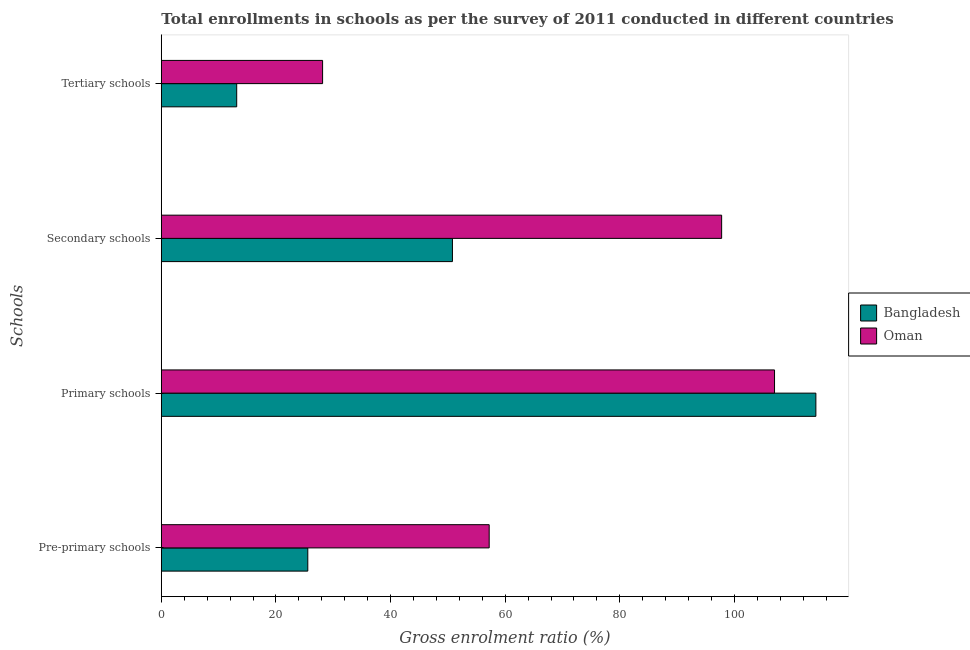How many different coloured bars are there?
Your answer should be very brief. 2. How many groups of bars are there?
Provide a short and direct response. 4. Are the number of bars per tick equal to the number of legend labels?
Provide a succinct answer. Yes. How many bars are there on the 1st tick from the top?
Offer a very short reply. 2. What is the label of the 1st group of bars from the top?
Your response must be concise. Tertiary schools. What is the gross enrolment ratio in tertiary schools in Oman?
Offer a terse response. 28.14. Across all countries, what is the maximum gross enrolment ratio in tertiary schools?
Offer a very short reply. 28.14. Across all countries, what is the minimum gross enrolment ratio in tertiary schools?
Ensure brevity in your answer.  13.15. In which country was the gross enrolment ratio in primary schools maximum?
Give a very brief answer. Bangladesh. In which country was the gross enrolment ratio in primary schools minimum?
Your answer should be compact. Oman. What is the total gross enrolment ratio in primary schools in the graph?
Your answer should be very brief. 221.19. What is the difference between the gross enrolment ratio in pre-primary schools in Bangladesh and that in Oman?
Offer a terse response. -31.65. What is the difference between the gross enrolment ratio in secondary schools in Oman and the gross enrolment ratio in tertiary schools in Bangladesh?
Make the answer very short. 84.61. What is the average gross enrolment ratio in pre-primary schools per country?
Give a very brief answer. 41.38. What is the difference between the gross enrolment ratio in primary schools and gross enrolment ratio in secondary schools in Bangladesh?
Offer a terse response. 63.41. In how many countries, is the gross enrolment ratio in secondary schools greater than 36 %?
Your response must be concise. 2. What is the ratio of the gross enrolment ratio in secondary schools in Bangladesh to that in Oman?
Make the answer very short. 0.52. Is the gross enrolment ratio in primary schools in Bangladesh less than that in Oman?
Offer a terse response. No. What is the difference between the highest and the second highest gross enrolment ratio in primary schools?
Make the answer very short. 7.21. What is the difference between the highest and the lowest gross enrolment ratio in secondary schools?
Your response must be concise. 46.97. In how many countries, is the gross enrolment ratio in primary schools greater than the average gross enrolment ratio in primary schools taken over all countries?
Provide a short and direct response. 1. What does the 1st bar from the top in Secondary schools represents?
Offer a very short reply. Oman. What does the 1st bar from the bottom in Primary schools represents?
Provide a succinct answer. Bangladesh. Is it the case that in every country, the sum of the gross enrolment ratio in pre-primary schools and gross enrolment ratio in primary schools is greater than the gross enrolment ratio in secondary schools?
Offer a very short reply. Yes. How many countries are there in the graph?
Make the answer very short. 2. Does the graph contain any zero values?
Make the answer very short. No. Does the graph contain grids?
Make the answer very short. No. Where does the legend appear in the graph?
Keep it short and to the point. Center right. What is the title of the graph?
Provide a short and direct response. Total enrollments in schools as per the survey of 2011 conducted in different countries. What is the label or title of the X-axis?
Keep it short and to the point. Gross enrolment ratio (%). What is the label or title of the Y-axis?
Provide a short and direct response. Schools. What is the Gross enrolment ratio (%) in Bangladesh in Pre-primary schools?
Provide a succinct answer. 25.56. What is the Gross enrolment ratio (%) of Oman in Pre-primary schools?
Provide a succinct answer. 57.2. What is the Gross enrolment ratio (%) in Bangladesh in Primary schools?
Make the answer very short. 114.2. What is the Gross enrolment ratio (%) in Oman in Primary schools?
Give a very brief answer. 106.99. What is the Gross enrolment ratio (%) in Bangladesh in Secondary schools?
Provide a succinct answer. 50.79. What is the Gross enrolment ratio (%) in Oman in Secondary schools?
Offer a terse response. 97.76. What is the Gross enrolment ratio (%) in Bangladesh in Tertiary schools?
Offer a terse response. 13.15. What is the Gross enrolment ratio (%) of Oman in Tertiary schools?
Make the answer very short. 28.14. Across all Schools, what is the maximum Gross enrolment ratio (%) in Bangladesh?
Your answer should be very brief. 114.2. Across all Schools, what is the maximum Gross enrolment ratio (%) of Oman?
Offer a terse response. 106.99. Across all Schools, what is the minimum Gross enrolment ratio (%) of Bangladesh?
Provide a short and direct response. 13.15. Across all Schools, what is the minimum Gross enrolment ratio (%) in Oman?
Give a very brief answer. 28.14. What is the total Gross enrolment ratio (%) of Bangladesh in the graph?
Provide a succinct answer. 203.71. What is the total Gross enrolment ratio (%) in Oman in the graph?
Your response must be concise. 290.09. What is the difference between the Gross enrolment ratio (%) in Bangladesh in Pre-primary schools and that in Primary schools?
Ensure brevity in your answer.  -88.65. What is the difference between the Gross enrolment ratio (%) of Oman in Pre-primary schools and that in Primary schools?
Keep it short and to the point. -49.78. What is the difference between the Gross enrolment ratio (%) in Bangladesh in Pre-primary schools and that in Secondary schools?
Keep it short and to the point. -25.24. What is the difference between the Gross enrolment ratio (%) in Oman in Pre-primary schools and that in Secondary schools?
Make the answer very short. -40.56. What is the difference between the Gross enrolment ratio (%) in Bangladesh in Pre-primary schools and that in Tertiary schools?
Make the answer very short. 12.4. What is the difference between the Gross enrolment ratio (%) of Oman in Pre-primary schools and that in Tertiary schools?
Ensure brevity in your answer.  29.07. What is the difference between the Gross enrolment ratio (%) of Bangladesh in Primary schools and that in Secondary schools?
Offer a terse response. 63.41. What is the difference between the Gross enrolment ratio (%) in Oman in Primary schools and that in Secondary schools?
Provide a succinct answer. 9.23. What is the difference between the Gross enrolment ratio (%) of Bangladesh in Primary schools and that in Tertiary schools?
Provide a succinct answer. 101.05. What is the difference between the Gross enrolment ratio (%) of Oman in Primary schools and that in Tertiary schools?
Give a very brief answer. 78.85. What is the difference between the Gross enrolment ratio (%) in Bangladesh in Secondary schools and that in Tertiary schools?
Your answer should be compact. 37.64. What is the difference between the Gross enrolment ratio (%) of Oman in Secondary schools and that in Tertiary schools?
Ensure brevity in your answer.  69.62. What is the difference between the Gross enrolment ratio (%) in Bangladesh in Pre-primary schools and the Gross enrolment ratio (%) in Oman in Primary schools?
Provide a short and direct response. -81.43. What is the difference between the Gross enrolment ratio (%) in Bangladesh in Pre-primary schools and the Gross enrolment ratio (%) in Oman in Secondary schools?
Keep it short and to the point. -72.2. What is the difference between the Gross enrolment ratio (%) of Bangladesh in Pre-primary schools and the Gross enrolment ratio (%) of Oman in Tertiary schools?
Provide a short and direct response. -2.58. What is the difference between the Gross enrolment ratio (%) of Bangladesh in Primary schools and the Gross enrolment ratio (%) of Oman in Secondary schools?
Your answer should be compact. 16.44. What is the difference between the Gross enrolment ratio (%) of Bangladesh in Primary schools and the Gross enrolment ratio (%) of Oman in Tertiary schools?
Ensure brevity in your answer.  86.07. What is the difference between the Gross enrolment ratio (%) of Bangladesh in Secondary schools and the Gross enrolment ratio (%) of Oman in Tertiary schools?
Provide a short and direct response. 22.66. What is the average Gross enrolment ratio (%) of Bangladesh per Schools?
Make the answer very short. 50.93. What is the average Gross enrolment ratio (%) in Oman per Schools?
Offer a very short reply. 72.52. What is the difference between the Gross enrolment ratio (%) of Bangladesh and Gross enrolment ratio (%) of Oman in Pre-primary schools?
Offer a terse response. -31.65. What is the difference between the Gross enrolment ratio (%) of Bangladesh and Gross enrolment ratio (%) of Oman in Primary schools?
Offer a very short reply. 7.21. What is the difference between the Gross enrolment ratio (%) in Bangladesh and Gross enrolment ratio (%) in Oman in Secondary schools?
Your answer should be compact. -46.97. What is the difference between the Gross enrolment ratio (%) in Bangladesh and Gross enrolment ratio (%) in Oman in Tertiary schools?
Your response must be concise. -14.98. What is the ratio of the Gross enrolment ratio (%) in Bangladesh in Pre-primary schools to that in Primary schools?
Give a very brief answer. 0.22. What is the ratio of the Gross enrolment ratio (%) of Oman in Pre-primary schools to that in Primary schools?
Give a very brief answer. 0.53. What is the ratio of the Gross enrolment ratio (%) in Bangladesh in Pre-primary schools to that in Secondary schools?
Provide a short and direct response. 0.5. What is the ratio of the Gross enrolment ratio (%) of Oman in Pre-primary schools to that in Secondary schools?
Your response must be concise. 0.59. What is the ratio of the Gross enrolment ratio (%) in Bangladesh in Pre-primary schools to that in Tertiary schools?
Keep it short and to the point. 1.94. What is the ratio of the Gross enrolment ratio (%) in Oman in Pre-primary schools to that in Tertiary schools?
Your response must be concise. 2.03. What is the ratio of the Gross enrolment ratio (%) of Bangladesh in Primary schools to that in Secondary schools?
Ensure brevity in your answer.  2.25. What is the ratio of the Gross enrolment ratio (%) in Oman in Primary schools to that in Secondary schools?
Your answer should be compact. 1.09. What is the ratio of the Gross enrolment ratio (%) in Bangladesh in Primary schools to that in Tertiary schools?
Offer a terse response. 8.68. What is the ratio of the Gross enrolment ratio (%) in Oman in Primary schools to that in Tertiary schools?
Offer a terse response. 3.8. What is the ratio of the Gross enrolment ratio (%) of Bangladesh in Secondary schools to that in Tertiary schools?
Your response must be concise. 3.86. What is the ratio of the Gross enrolment ratio (%) in Oman in Secondary schools to that in Tertiary schools?
Keep it short and to the point. 3.47. What is the difference between the highest and the second highest Gross enrolment ratio (%) in Bangladesh?
Your response must be concise. 63.41. What is the difference between the highest and the second highest Gross enrolment ratio (%) of Oman?
Give a very brief answer. 9.23. What is the difference between the highest and the lowest Gross enrolment ratio (%) in Bangladesh?
Your answer should be compact. 101.05. What is the difference between the highest and the lowest Gross enrolment ratio (%) of Oman?
Ensure brevity in your answer.  78.85. 